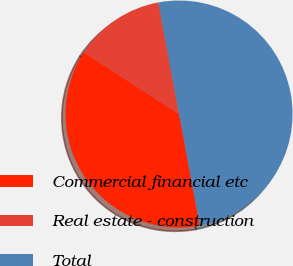Convert chart to OTSL. <chart><loc_0><loc_0><loc_500><loc_500><pie_chart><fcel>Commercial financial etc<fcel>Real estate - construction<fcel>Total<nl><fcel>37.06%<fcel>12.94%<fcel>50.0%<nl></chart> 